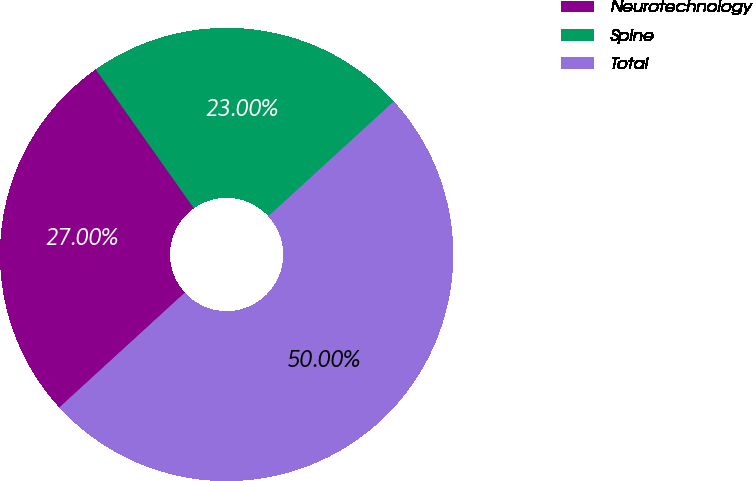<chart> <loc_0><loc_0><loc_500><loc_500><pie_chart><fcel>Neurotechnology<fcel>Spine<fcel>Total<nl><fcel>27.0%<fcel>23.0%<fcel>50.0%<nl></chart> 